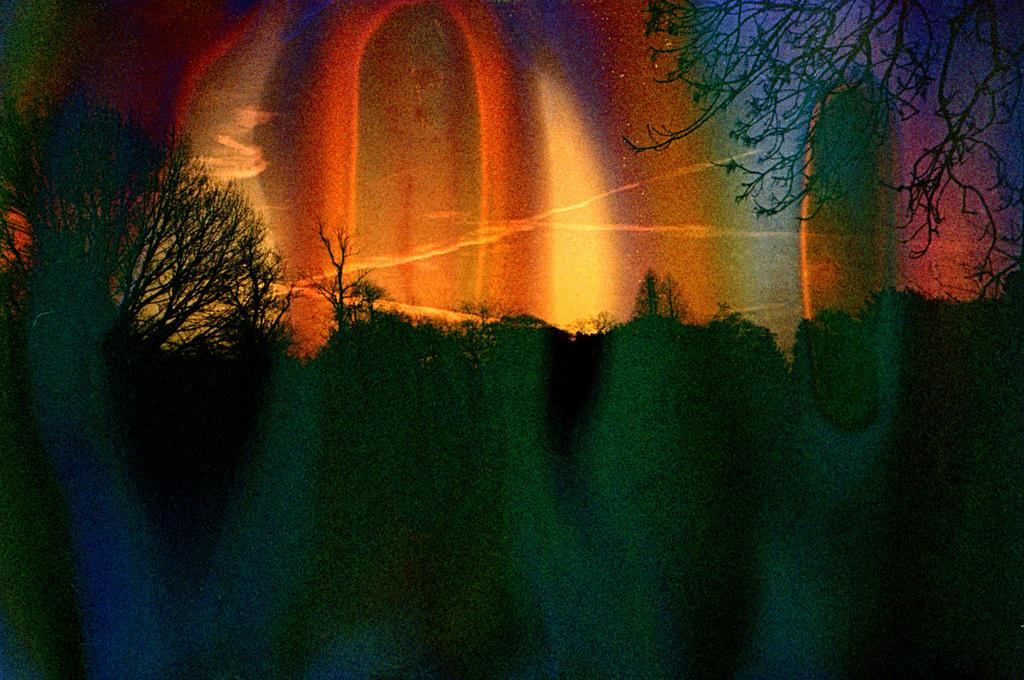What type of image is being described? The image is an edited picture. What can be seen in the image besides the edited elements? There are trees in the image. What is visible at the top of the image? The sky is visible at the top of the image. What can be observed in the sky? There are clouds in the sky. How would you describe the color scheme of the image? The image contains different colors. What type of fowl can be seen swimming in the liquid in the image? There is no fowl or liquid present in the image; it features trees, the sky, and clouds. How many quinces are visible in the image? There are no quinces present in the image. 